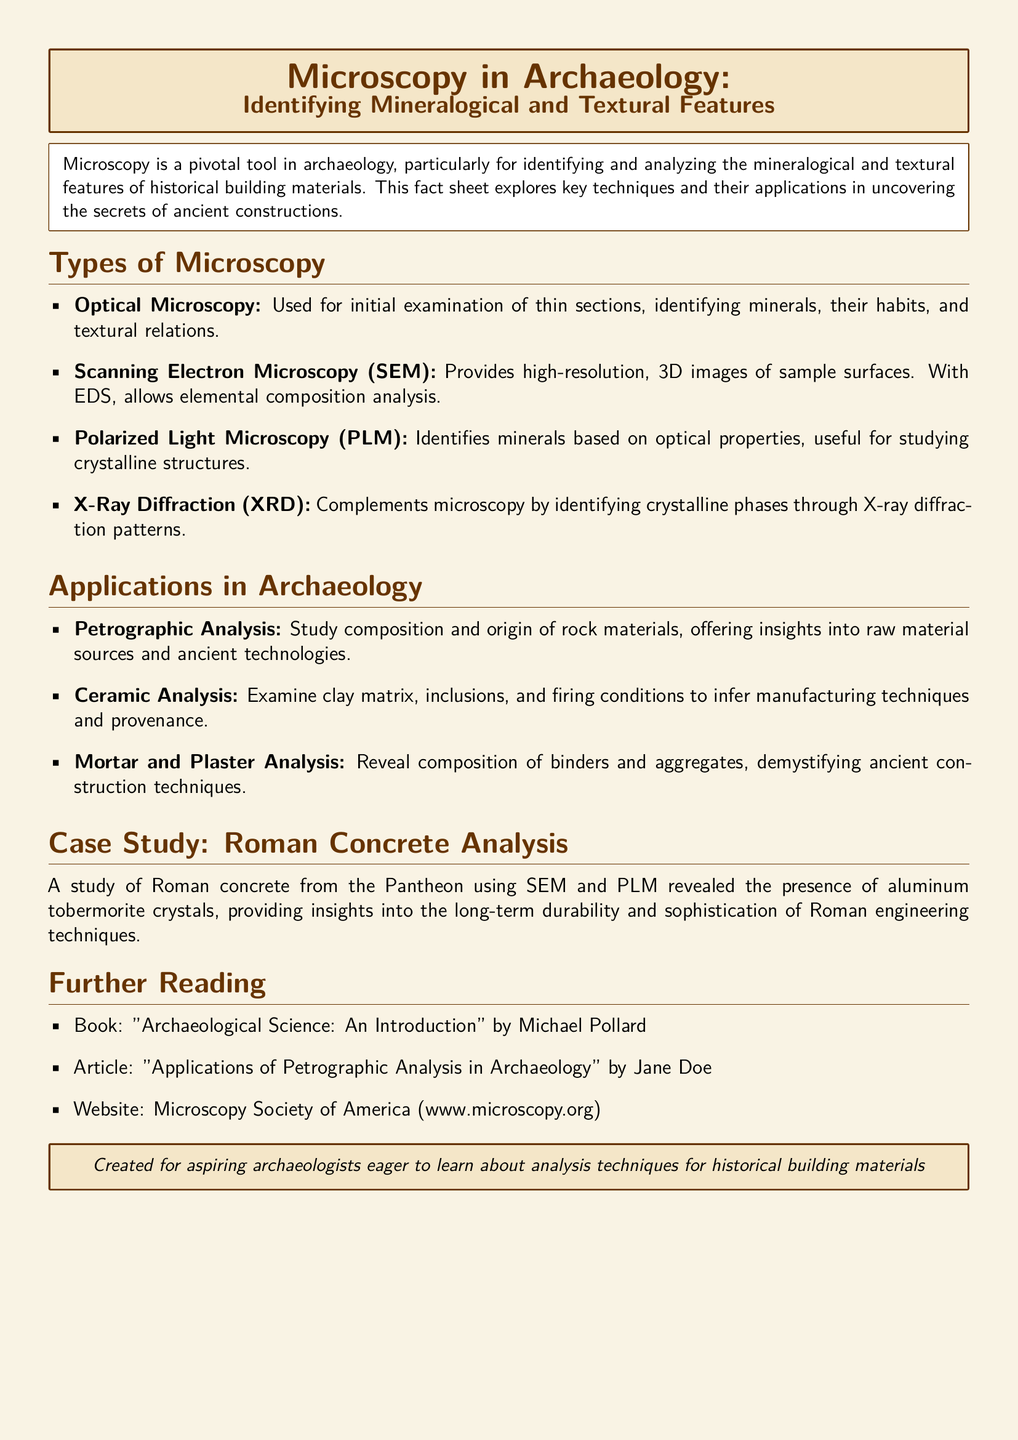what is the primary tool in archaeology for analyzing historical building materials? The document states that microscopy is a pivotal tool in archaeology, particularly for identifying and analyzing building materials.
Answer: microscopy which microscopy technique provides high-resolution, 3D images? The document mentions Scanning Electron Microscopy (SEM) as the technique that provides high-resolution, 3D images of sample surfaces.
Answer: Scanning Electron Microscopy what does X-Ray Diffraction complement in microscopy? According to the document, X-Ray Diffraction (XRD) complements microscopy by identifying crystalline phases through diffraction patterns.
Answer: microscopy name one application of Petrographic Analysis in archaeology. The document states that Petrographic Analysis studies the composition and origin of rock materials, which offers insights into raw material sources.
Answer: raw material sources which ancient structure's concrete was analyzed in the case study? The case study mentions the analysis of Roman concrete from the Pantheon.
Answer: Pantheon who is the author of a recommended book for further reading? The document lists "Archaeological Science: An Introduction" by Michael Pollard as a recommended reading.
Answer: Michael Pollard what type of microscopic examination is used for initial mineral identification? Optical Microscopy is described as the method used for initial examination of thin sections and mineral identification.
Answer: Optical Microscopy what kind of crystals were found in the Roman concrete analysis? The case study notes the presence of aluminum tobermorite crystals in the analysis of Roman concrete.
Answer: aluminum tobermorite crystals how is polarized light microscopy beneficial in archaeology? Polarized Light Microscopy (PLM) is used for identifying minerals based on optical properties, aiding in the study of crystalline structures.
Answer: identifying minerals 